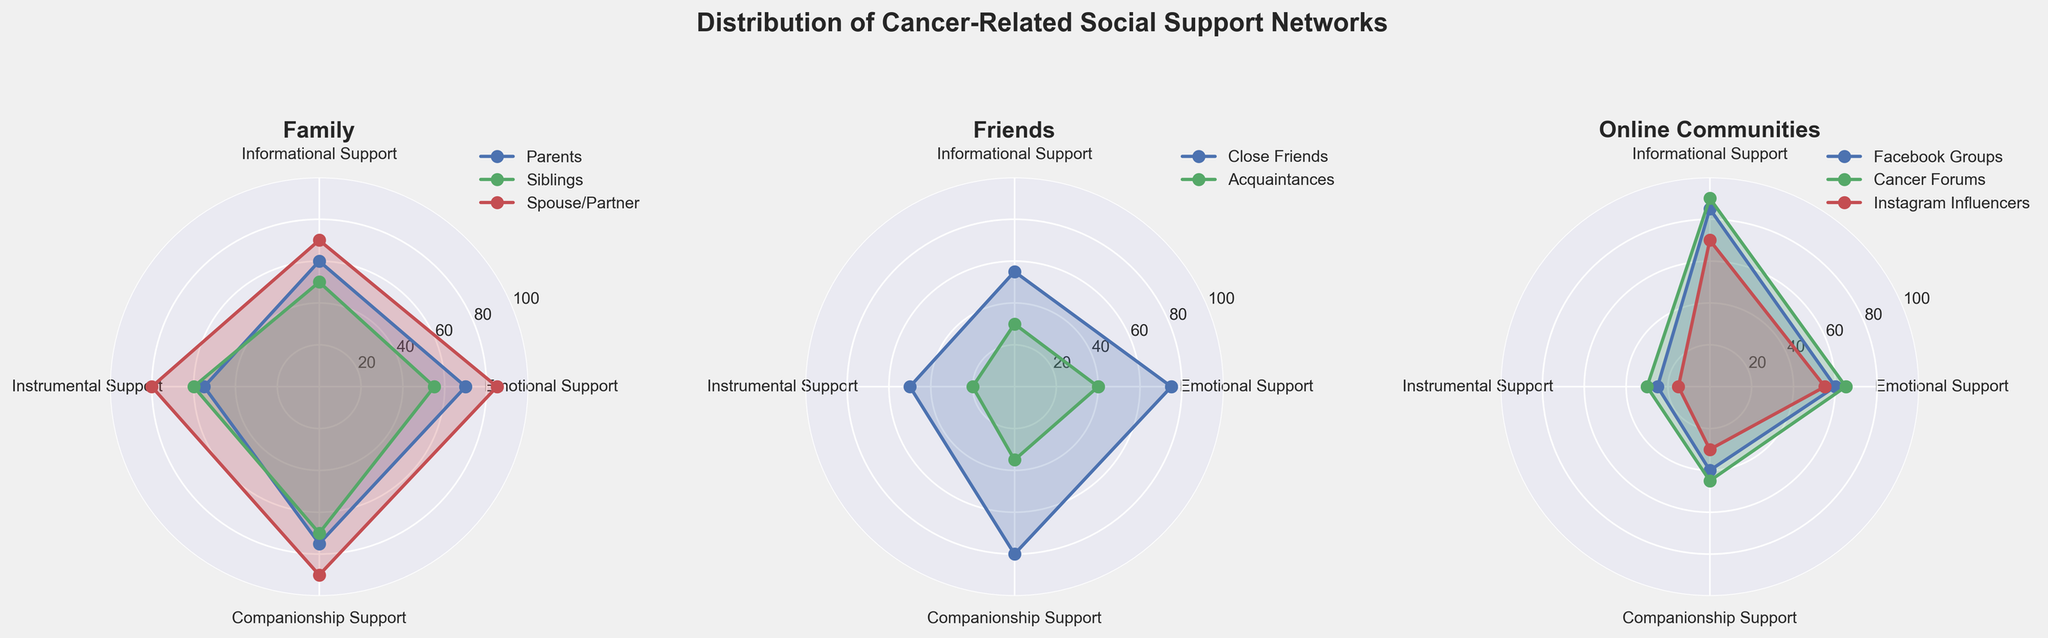What is the title of the figure? The title is usually placed at the top of the figure and describes its content. Here, it reads "Distribution of Cancer-Related Social Support Networks."
Answer: Distribution of Cancer-Related Social Support Networks Which category shows the highest level of emotional support in the family subgroup? In the family radar chart, the segment with the highest value in the emotional support axis is the spouse/partner, with a value of 85.
Answer: Spouse/Partner Which type of support does "Cancer Forums" in the online communities category excel at providing? By looking at the data points on the radar chart for "Cancer Forums" in the online communities subplot, we see the highest value is under Informational Support, which is 90.
Answer: Informational Support Which subgroup among friends provides the least instrumental support? In the friends category radar chart, acquaintances show the lowest value in instrumental support, which is 20.
Answer: Acquaintances Compare the companionship support provided by close friends and cancer forums. Which one is higher? By examining the radar chart, we see close friends provide companionship support at 80, whereas cancer forums provide it at 45. Therefore, close friends have higher companionship support.
Answer: Close Friends What is the average emotional support value provided by the family subgroup? The emotional support values for family members (parents, siblings, spouse/partner) are 70, 55, and 85, respectively. Adding these (70 + 55 + 85) gives 210, and dividing by 3 gives an average of 70.
Answer: 70 Which subgroup provides the highest overall support in any category across all groups? The family subgroup's spouse/partner provides the highest overall support at 90 in companionship support as per the radar plots.
Answer: Spouse/Partner What is the difference between the informational support provided by Facebook Groups and Instagram Influencers? Facebook Groups provide 85 in informational support, while Instagram Influencers provide 70. The difference is 85 - 70 = 15.
Answer: 15 Identify a category where Instagram Influencers provide higher support compared to Acquaintances. Looking at the radar chart, Instagram Influencers provide higher informational support (70) compared to acquaintances, which provide 30.
Answer: Informational Support What is the sum of instrumental support values for family and friends subgroups? Summing up instrumental support in the family category (55 + 60 + 80 = 195) and friends category (50 + 20 = 70) results in 195 + 70 = 265.
Answer: 265 